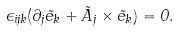Convert formula to latex. <formula><loc_0><loc_0><loc_500><loc_500>\epsilon _ { i j k } ( \partial _ { j } { \vec { e } } _ { k } + { \vec { A } } _ { j } \times { \vec { e } } _ { k } ) = 0 .</formula> 